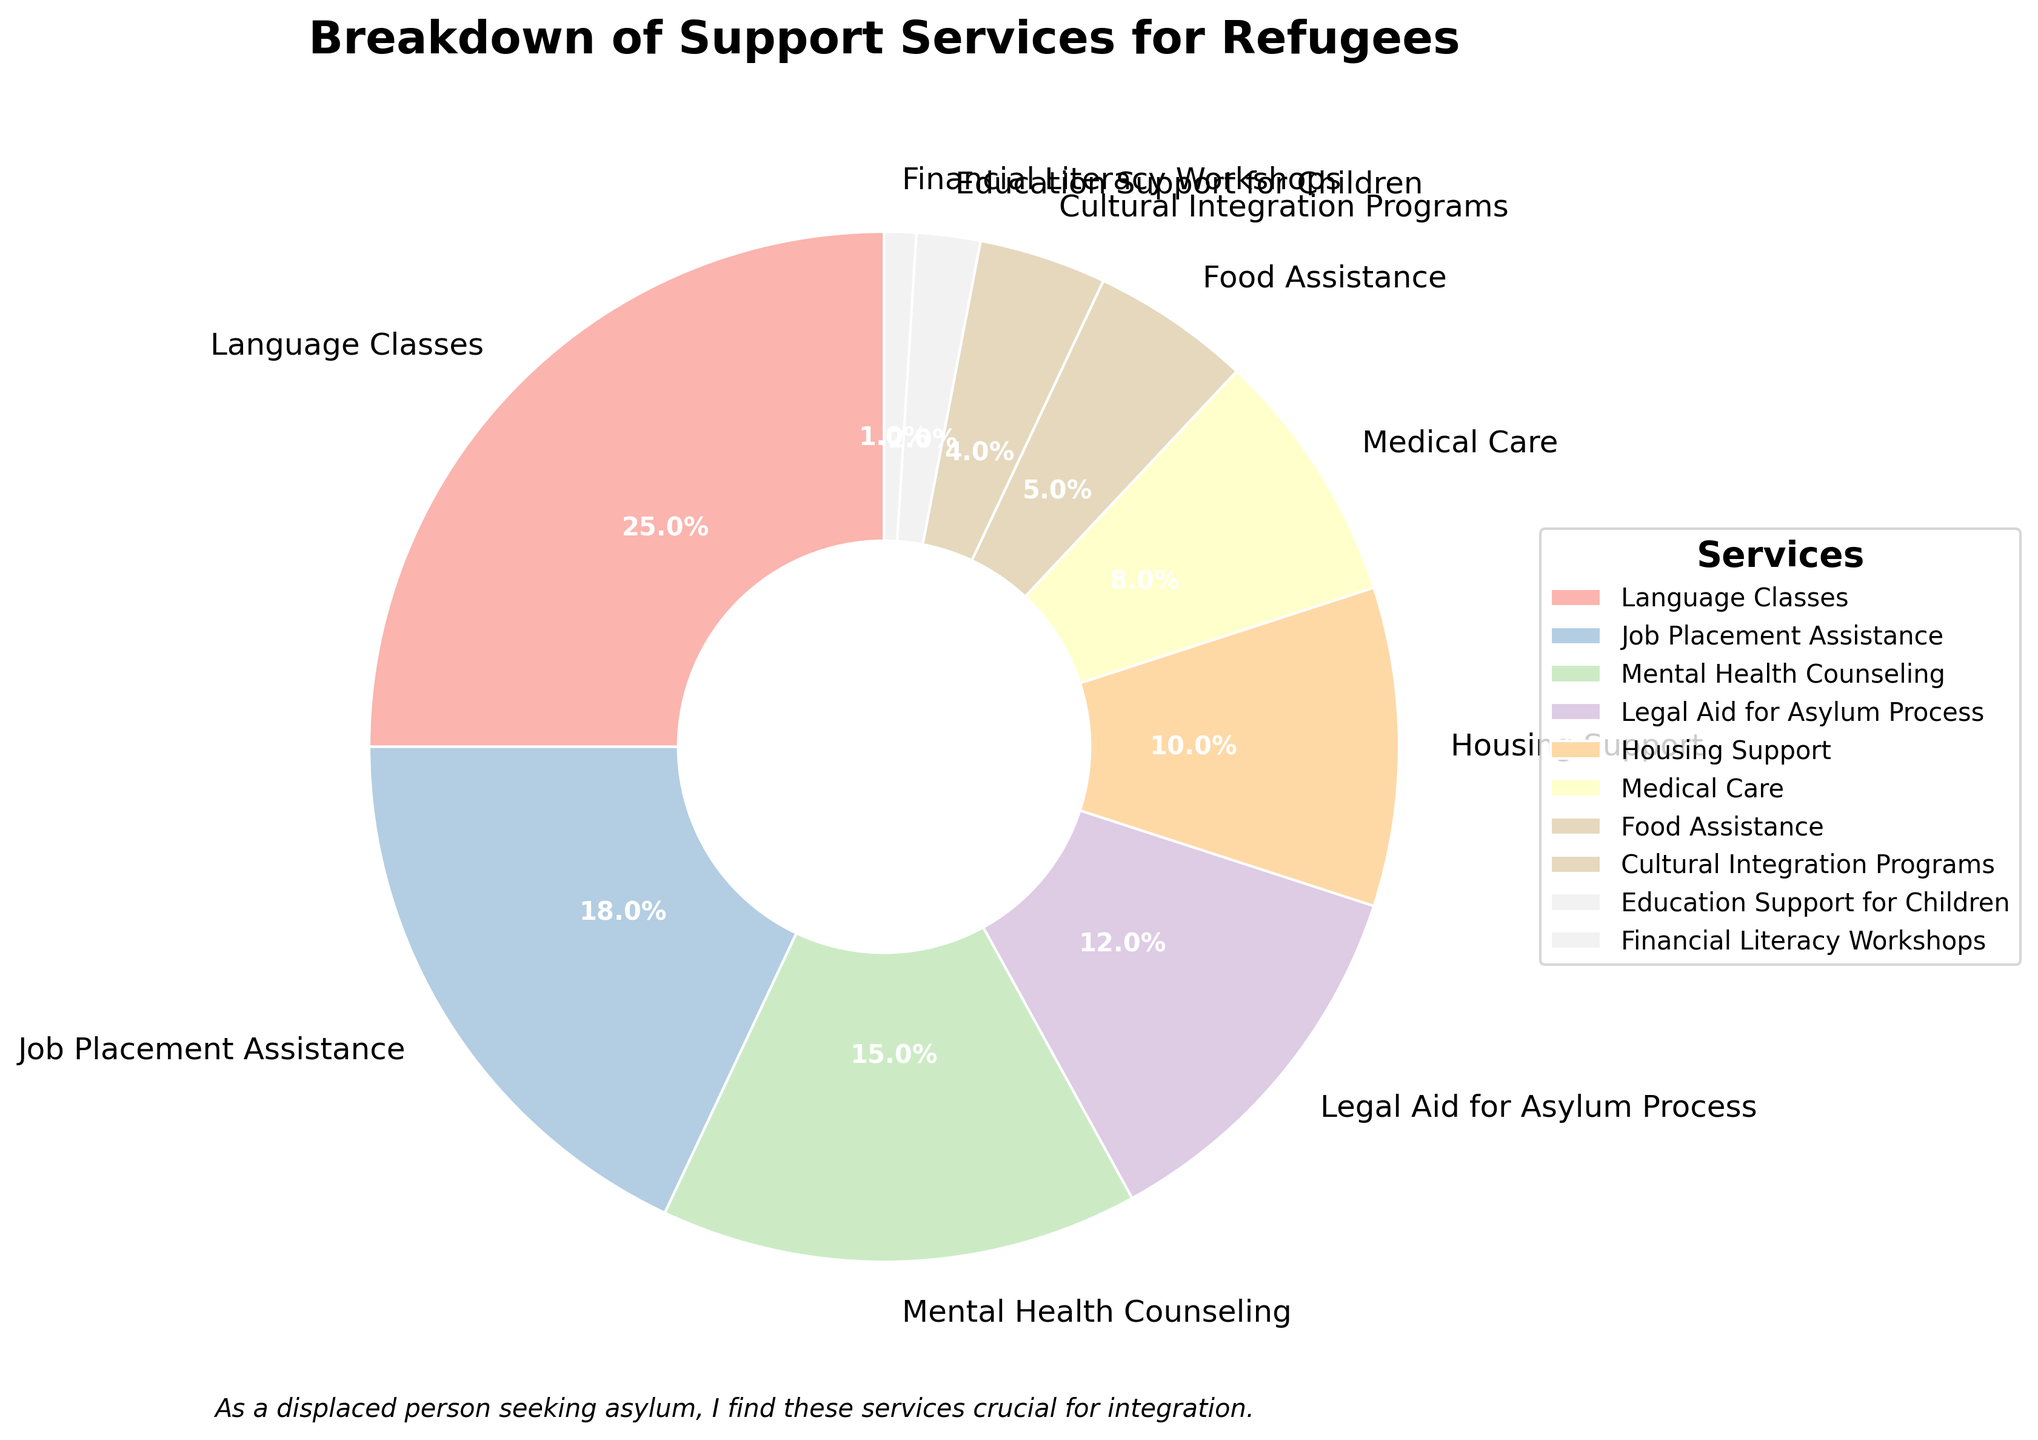Which support service has the highest utilization by refugees? Look at the section with the largest percentage in the pie chart. This represents the most utilized support service by refugees. In this chart, the largest section is "Language Classes" at 25%.
Answer: Language Classes Which two services are used by exactly half of the refugees combined? Add the percentages of different services until the total reaches 50%. Adding 25% (Language Classes) and 25% (Mental Health Counseling and Legal Aid for Asylum Process) covers half the refugees.
Answer: Language Classes and Job Placement Assistance Is Housing Support utilized more than Medical Care? Find the percentages for Housing Support and Medical Care, then compare them. Housing Support is at 10% while Medical Care is at 8%.
Answer: Yes Which services combined make up one-fourth of the support utilization? To find a combination equaling 25%, add the percentages of different services until the total reaches 25%. Adding Medical Care (8%), Food Assistance (5%), Cultural Integration Programs (4%), Education Support for Children (2%), and Financial Literacy Workshops (1%) together equals 20%. Adding another service (Legal Aid for Asylum Process at 12%) would exceed 25%, so it's impossible with the lowest percentage categories.
Answer: Impossible with the lowest percentage categories What is the combined percentage for the three least utilized services? Find the percentages for the three services with the smallest slices and add them together. The percentages for Education Support for Children, Financial Literacy Workshops, and Cultural Integration Programs are 2%, 1%, and 4% respectively. Adding them together gives 2% + 1% + 4% = 7%.
Answer: 7% Which service does more than double the utilization compared to Food Assistance? Find the percentage for Food Assistance and services that are more than double its percentage. Food Assistance is at 5%. Any service above 10% is considered more than double. Housing Support (10%) meets exactly double but not more. Hence, Job Placement Assistance (18%), Mental Health Counseling (15%), Language Classes (25%), and Legal Aid for Asylum Process (12%) are candidates.
Answer: Language Classes, Job Placement Assistance, Mental Health Counseling, Legal Aid for Asylum Process Is there any service that has exactly half the utilization percentage of Housing Support? Housing Support is utilized by 10%, so half would be 5%. Check services at 5%, which is Food Assistance.
Answer: Yes, Food Assistance What is the percentage difference between the most and least utilized services? Find the percentages for the most utilized (Language Classes, 25%) and least utilized (Financial Literacy Workshops, 1%) services, then subtract the smaller from the larger. 25% - 1% = 24%.
Answer: 24% How many services have a utilization percentage less than 10%? Count the number of services whose slice indicates a percentage smaller than 10%. These are Medical Care (8%), Food Assistance (5%), Cultural Integration Programs (4%), Education Support for Children (2%), and Financial Literacy Workshops (1%).
Answer: 5 What is the total percentage of all services providing direct financial or material aid (like food and housing)? Add the percentages for services directly offering material assistance: Food Assistance (5%) and Housing Support (10%). 5% + 10% = 15%.
Answer: 15% 